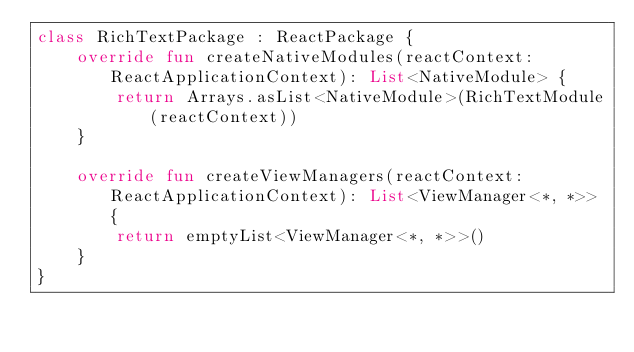Convert code to text. <code><loc_0><loc_0><loc_500><loc_500><_Kotlin_>class RichTextPackage : ReactPackage {
    override fun createNativeModules(reactContext: ReactApplicationContext): List<NativeModule> {
        return Arrays.asList<NativeModule>(RichTextModule(reactContext))
    }

    override fun createViewManagers(reactContext: ReactApplicationContext): List<ViewManager<*, *>> {
        return emptyList<ViewManager<*, *>>()
    }
}
</code> 